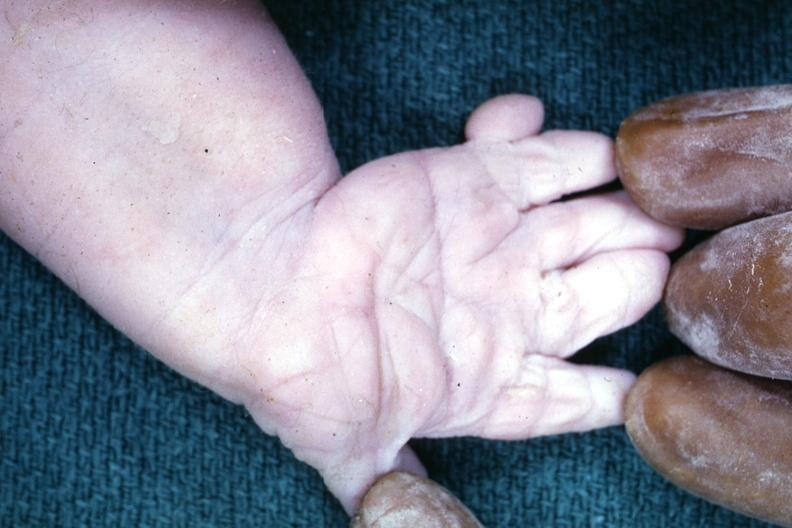s hand present?
Answer the question using a single word or phrase. Yes 